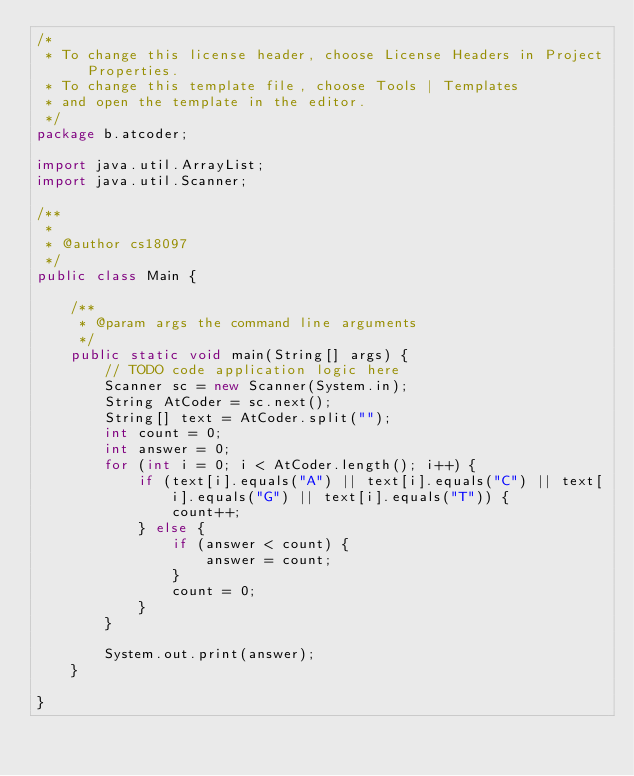Convert code to text. <code><loc_0><loc_0><loc_500><loc_500><_Java_>/*
 * To change this license header, choose License Headers in Project Properties.
 * To change this template file, choose Tools | Templates
 * and open the template in the editor.
 */
package b.atcoder;

import java.util.ArrayList;
import java.util.Scanner;

/**
 *
 * @author cs18097
 */
public class Main {

    /**
     * @param args the command line arguments
     */
    public static void main(String[] args) {
        // TODO code application logic here
        Scanner sc = new Scanner(System.in);
        String AtCoder = sc.next();
        String[] text = AtCoder.split("");
        int count = 0;
        int answer = 0;
        for (int i = 0; i < AtCoder.length(); i++) {
            if (text[i].equals("A") || text[i].equals("C") || text[i].equals("G") || text[i].equals("T")) {
                count++;
            } else {
                if (answer < count) {
                    answer = count;
                }
                count = 0;
            }
        }

        System.out.print(answer);
    }

}
</code> 